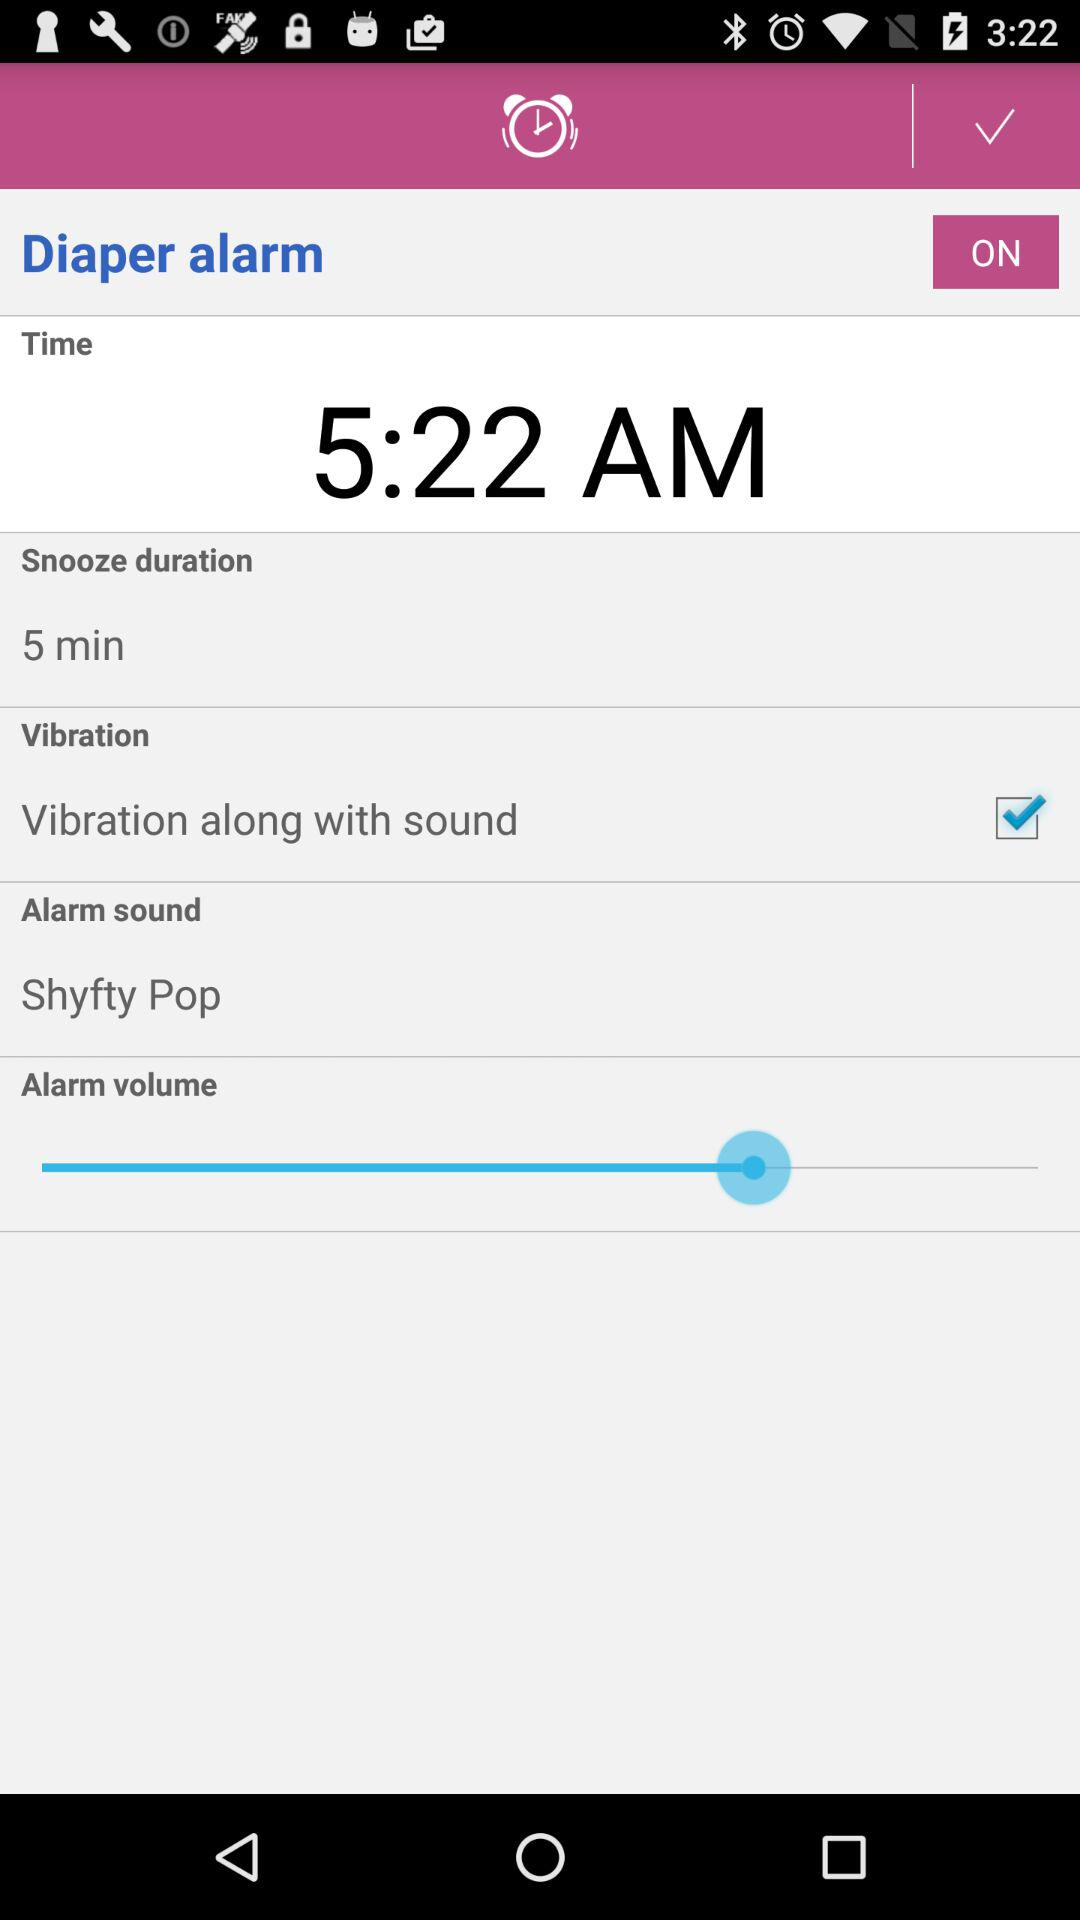What is the alarm sound? The alarm sound is "Shyfty Pop". 